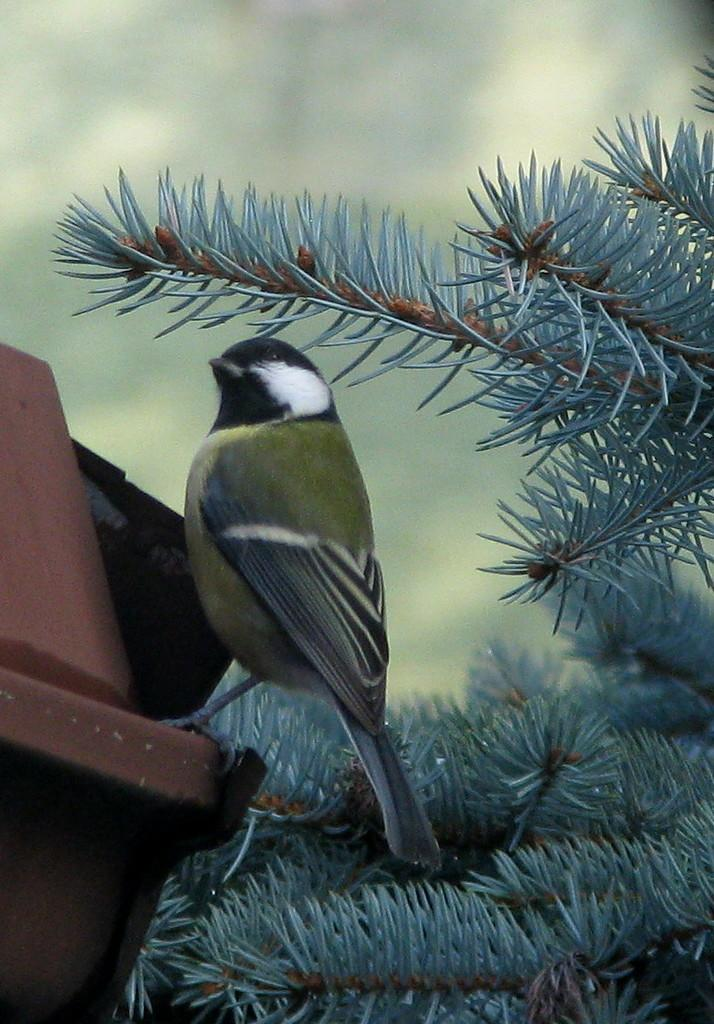What type of animal can be seen in the image? There is a bird in the image. Where is the bird located in the image? The bird is on the right side of the image. What is the bird sitting on? The bird is sitting on a brown object. What other living organism is present in the image? There is a plant in the image. Where is the plant located in the image? The plant is on the right side of the image. What feature of the plant is mentioned in the facts? The plant has leaves. Can you describe the background of the image? The backdrop of the image is blurred. What is the reaction of the bird when the planes fly overhead in the image? There are no planes mentioned in the image, so it is not possible to determine the bird's reaction to them. 